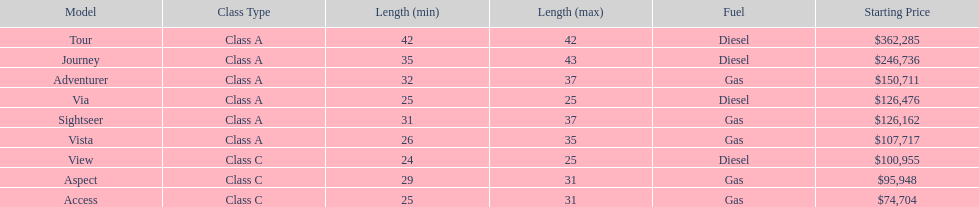Which model is at the top of the list with the highest starting price? Tour. 